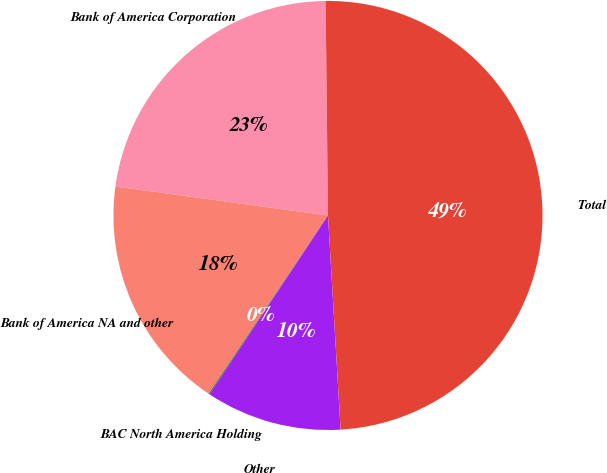Convert chart. <chart><loc_0><loc_0><loc_500><loc_500><pie_chart><fcel>Bank of America Corporation<fcel>Bank of America NA and other<fcel>BAC North America Holding<fcel>Other<fcel>Total<nl><fcel>22.67%<fcel>17.76%<fcel>0.08%<fcel>10.25%<fcel>49.23%<nl></chart> 